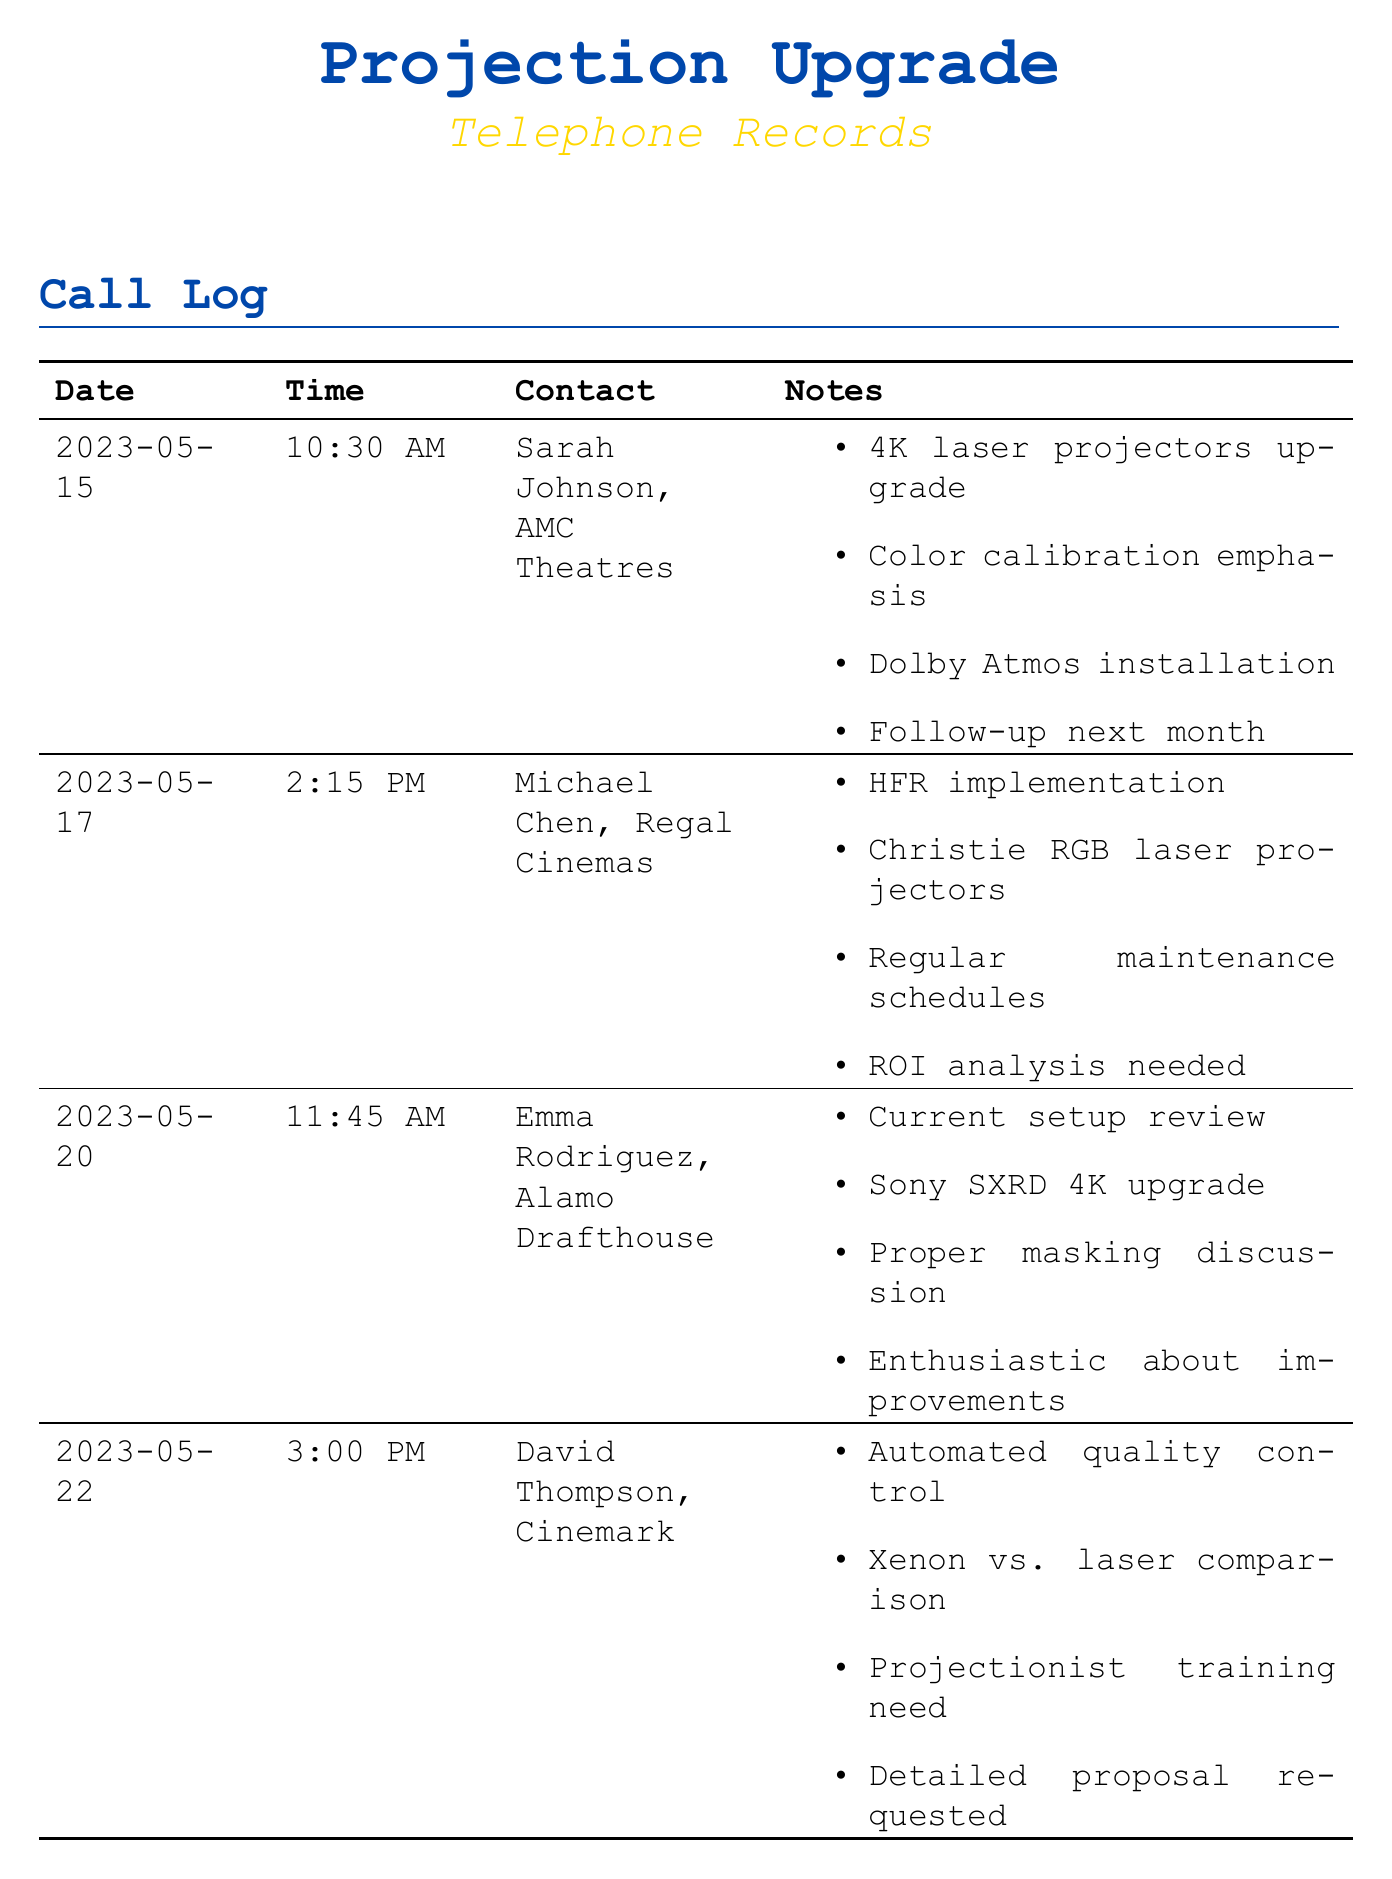What is the date of the call with Sarah Johnson? The date of the call is noted in the record for Sarah Johnson, which is May 15, 2023.
Answer: May 15, 2023 What was emphasized during the call with Sarah Johnson? The notes for the call with Sarah Johnson specifically mention an emphasis on color calibration.
Answer: Color calibration Which company is associated with Michael Chen? The call log indicates that Michael Chen is associated with Regal Cinemas.
Answer: Regal Cinemas What type of projectors are discussed in the call with David Thompson? The notes list a comparison between Xenon and laser projectors during the call with David Thompson.
Answer: Xenon vs. laser What is mentioned about projectionist training in David Thompson's call? The notes suggest a need for projectionist training was discussed in the call with David Thompson.
Answer: Need What follow-up action is indicated in Sarah Johnson's call? The notes state a follow-up is planned for the next month following the call with Sarah Johnson.
Answer: Next month Which installation is discussed with Sarah Johnson? The call notes specify that Dolby Atmos installation was mentioned in the discussion with Sarah Johnson.
Answer: Dolby Atmos installation What was discussed during the call with Emma Rodriguez? The call log indicates a current setup review was part of the discussion with Emma Rodriguez.
Answer: Current setup review What kind of projectors are suggested by Michael Chen? The notes refer to Christie RGB laser projectors as suggested by Michael Chen.
Answer: Christie RGB laser projectors 